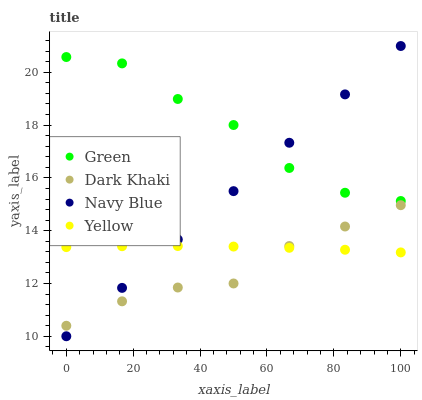Does Dark Khaki have the minimum area under the curve?
Answer yes or no. Yes. Does Green have the maximum area under the curve?
Answer yes or no. Yes. Does Navy Blue have the minimum area under the curve?
Answer yes or no. No. Does Navy Blue have the maximum area under the curve?
Answer yes or no. No. Is Navy Blue the smoothest?
Answer yes or no. Yes. Is Green the roughest?
Answer yes or no. Yes. Is Green the smoothest?
Answer yes or no. No. Is Navy Blue the roughest?
Answer yes or no. No. Does Navy Blue have the lowest value?
Answer yes or no. Yes. Does Green have the lowest value?
Answer yes or no. No. Does Navy Blue have the highest value?
Answer yes or no. Yes. Does Green have the highest value?
Answer yes or no. No. Is Yellow less than Green?
Answer yes or no. Yes. Is Green greater than Dark Khaki?
Answer yes or no. Yes. Does Navy Blue intersect Yellow?
Answer yes or no. Yes. Is Navy Blue less than Yellow?
Answer yes or no. No. Is Navy Blue greater than Yellow?
Answer yes or no. No. Does Yellow intersect Green?
Answer yes or no. No. 